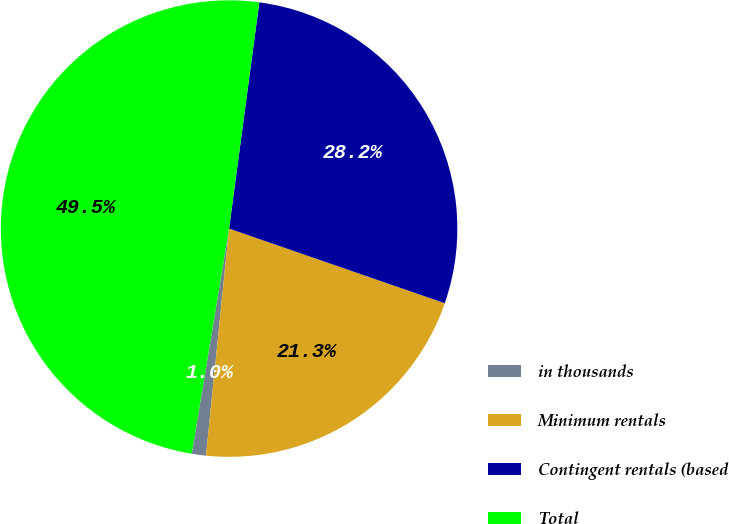<chart> <loc_0><loc_0><loc_500><loc_500><pie_chart><fcel>in thousands<fcel>Minimum rentals<fcel>Contingent rentals (based<fcel>Total<nl><fcel>1.0%<fcel>21.31%<fcel>28.19%<fcel>49.5%<nl></chart> 